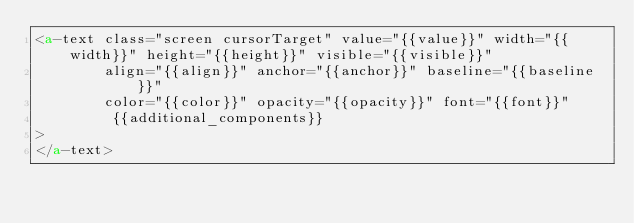Convert code to text. <code><loc_0><loc_0><loc_500><loc_500><_HTML_><a-text class="screen cursorTarget" value="{{value}}" width="{{width}}" height="{{height}}" visible="{{visible}}"
        align="{{align}}" anchor="{{anchor}}" baseline="{{baseline}}" 
        color="{{color}}" opacity="{{opacity}}" font="{{font}}" 
         {{additional_components}}
>
</a-text>
</code> 